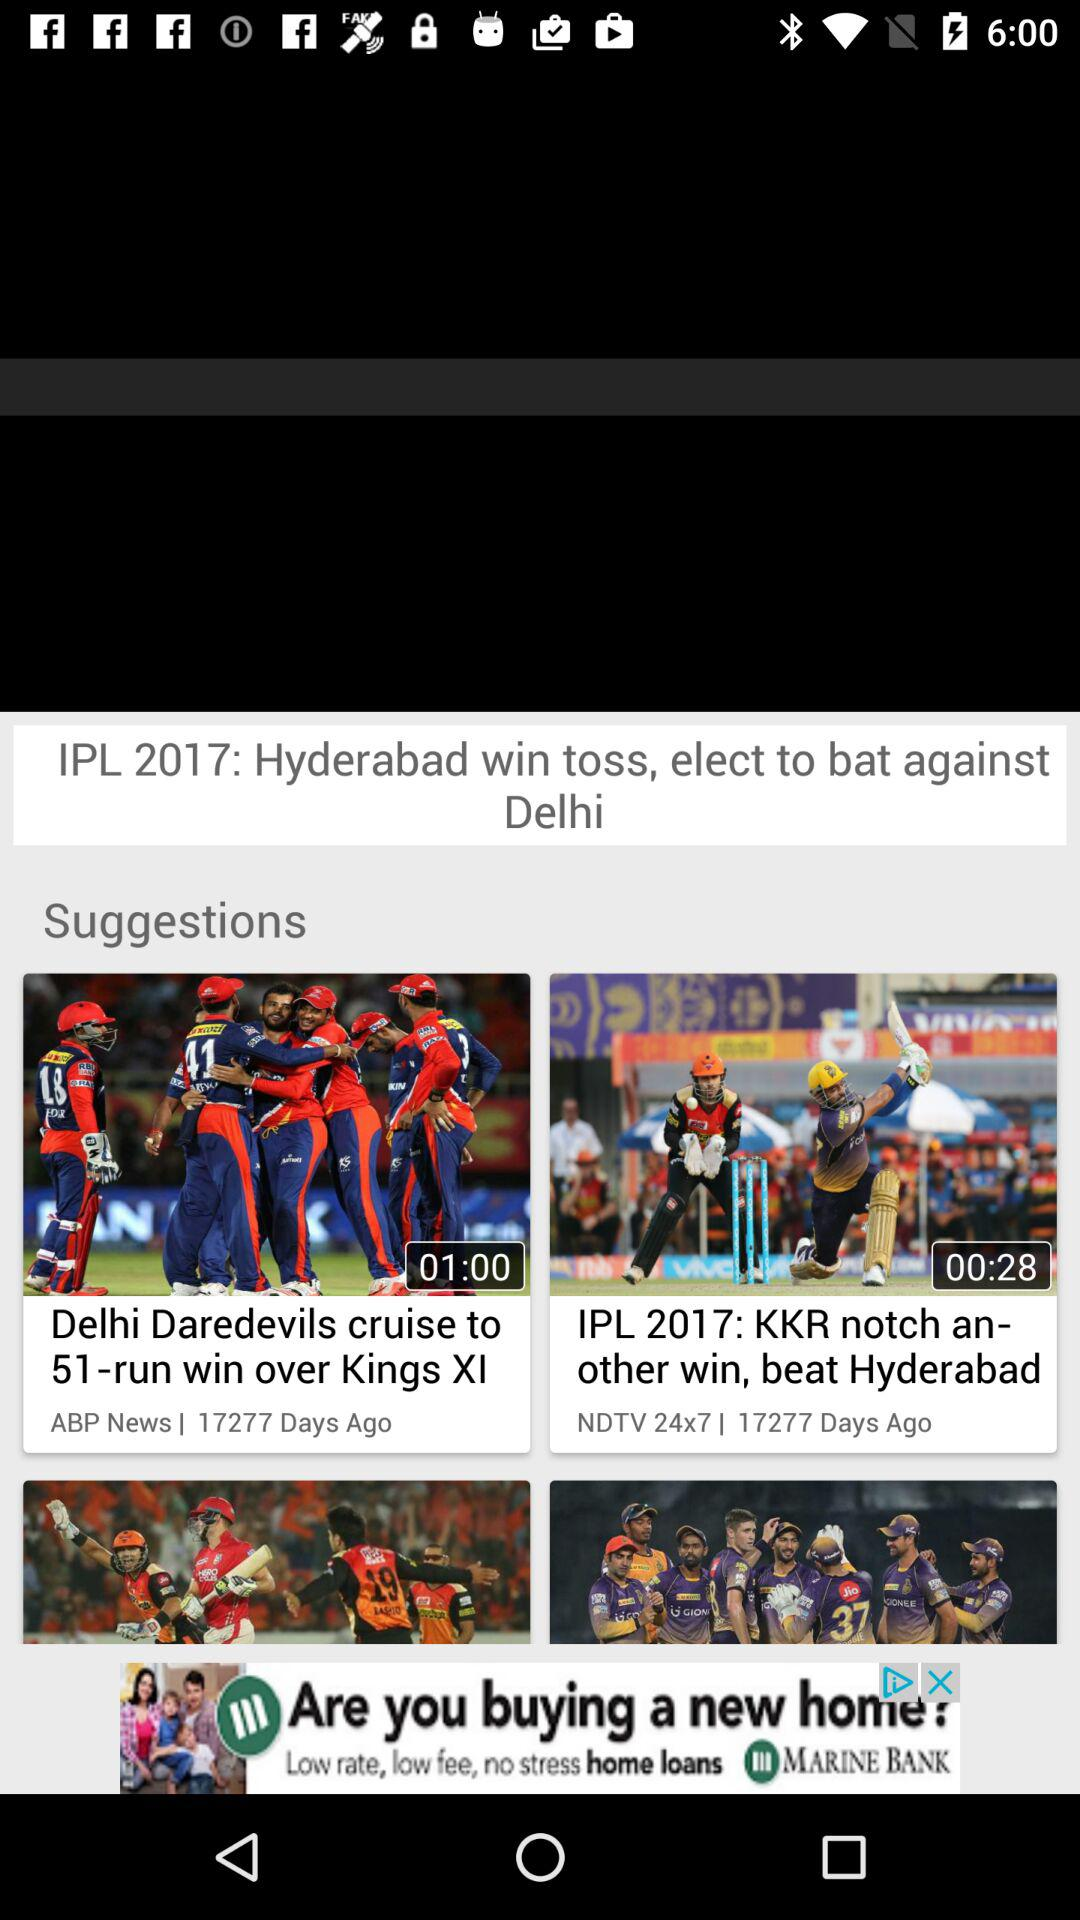How many days ago was the news "Delhi Daredevils cruise to 51-run win over Kings XI" posted? The news "Delhi Daredevils cruise to 51-run win over Kings XI" was posted 17277 days ago. 